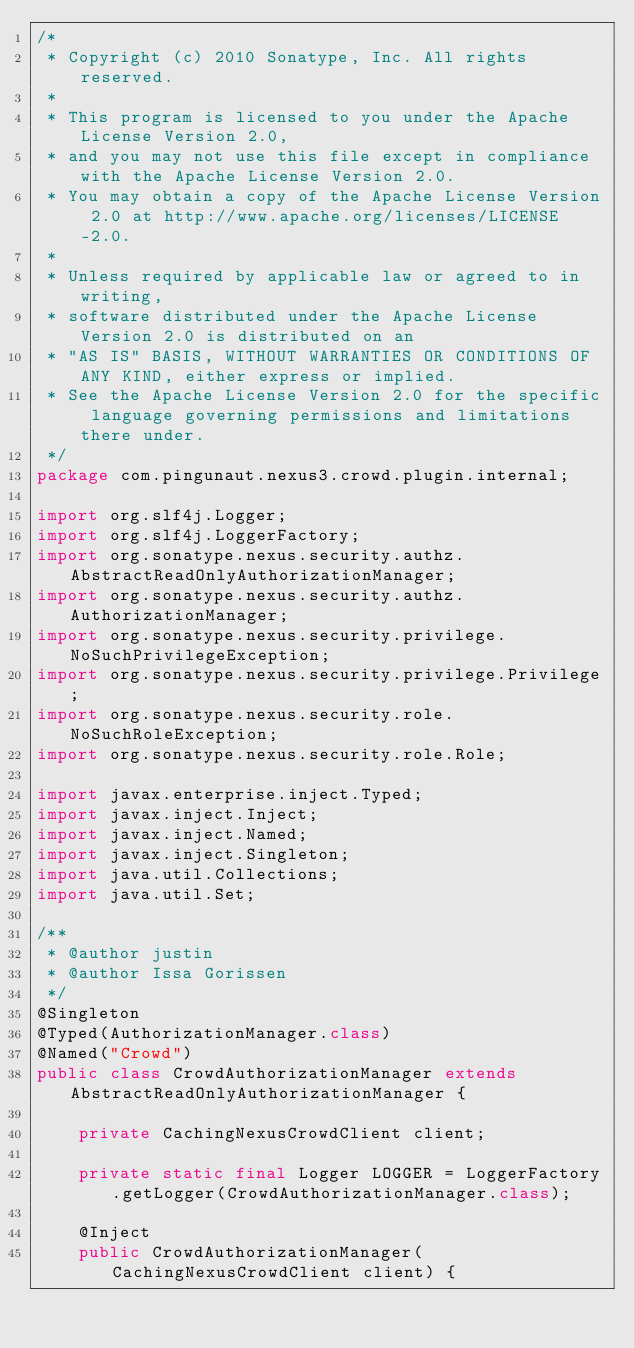<code> <loc_0><loc_0><loc_500><loc_500><_Java_>/*
 * Copyright (c) 2010 Sonatype, Inc. All rights reserved.
 *
 * This program is licensed to you under the Apache License Version 2.0,
 * and you may not use this file except in compliance with the Apache License Version 2.0.
 * You may obtain a copy of the Apache License Version 2.0 at http://www.apache.org/licenses/LICENSE-2.0.
 *
 * Unless required by applicable law or agreed to in writing,
 * software distributed under the Apache License Version 2.0 is distributed on an
 * "AS IS" BASIS, WITHOUT WARRANTIES OR CONDITIONS OF ANY KIND, either express or implied.
 * See the Apache License Version 2.0 for the specific language governing permissions and limitations there under.
 */
package com.pingunaut.nexus3.crowd.plugin.internal;

import org.slf4j.Logger;
import org.slf4j.LoggerFactory;
import org.sonatype.nexus.security.authz.AbstractReadOnlyAuthorizationManager;
import org.sonatype.nexus.security.authz.AuthorizationManager;
import org.sonatype.nexus.security.privilege.NoSuchPrivilegeException;
import org.sonatype.nexus.security.privilege.Privilege;
import org.sonatype.nexus.security.role.NoSuchRoleException;
import org.sonatype.nexus.security.role.Role;

import javax.enterprise.inject.Typed;
import javax.inject.Inject;
import javax.inject.Named;
import javax.inject.Singleton;
import java.util.Collections;
import java.util.Set;

/**
 * @author justin
 * @author Issa Gorissen
 */
@Singleton
@Typed(AuthorizationManager.class)
@Named("Crowd")
public class CrowdAuthorizationManager extends AbstractReadOnlyAuthorizationManager {

	private CachingNexusCrowdClient client;

	private static final Logger LOGGER = LoggerFactory.getLogger(CrowdAuthorizationManager.class);

	@Inject
	public CrowdAuthorizationManager(CachingNexusCrowdClient client) {</code> 